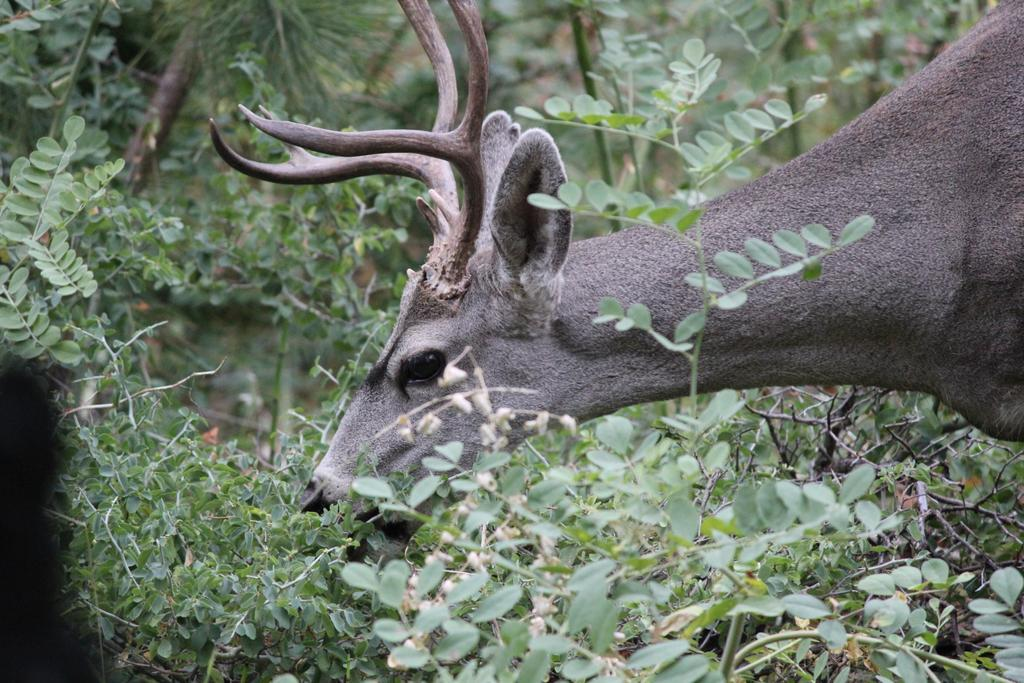What type of animal can be seen in the picture? There is a white-tailed deer in the picture. What else is present in the picture besides the deer? There are plants in the picture. What advertisement is being displayed on the deer's antlers in the picture? There is no advertisement present in the image; it features a white-tailed deer and plants. 